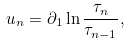<formula> <loc_0><loc_0><loc_500><loc_500>u _ { n } = \partial _ { 1 } \ln \frac { \tau _ { n } } { \tau _ { n - 1 } } ,</formula> 